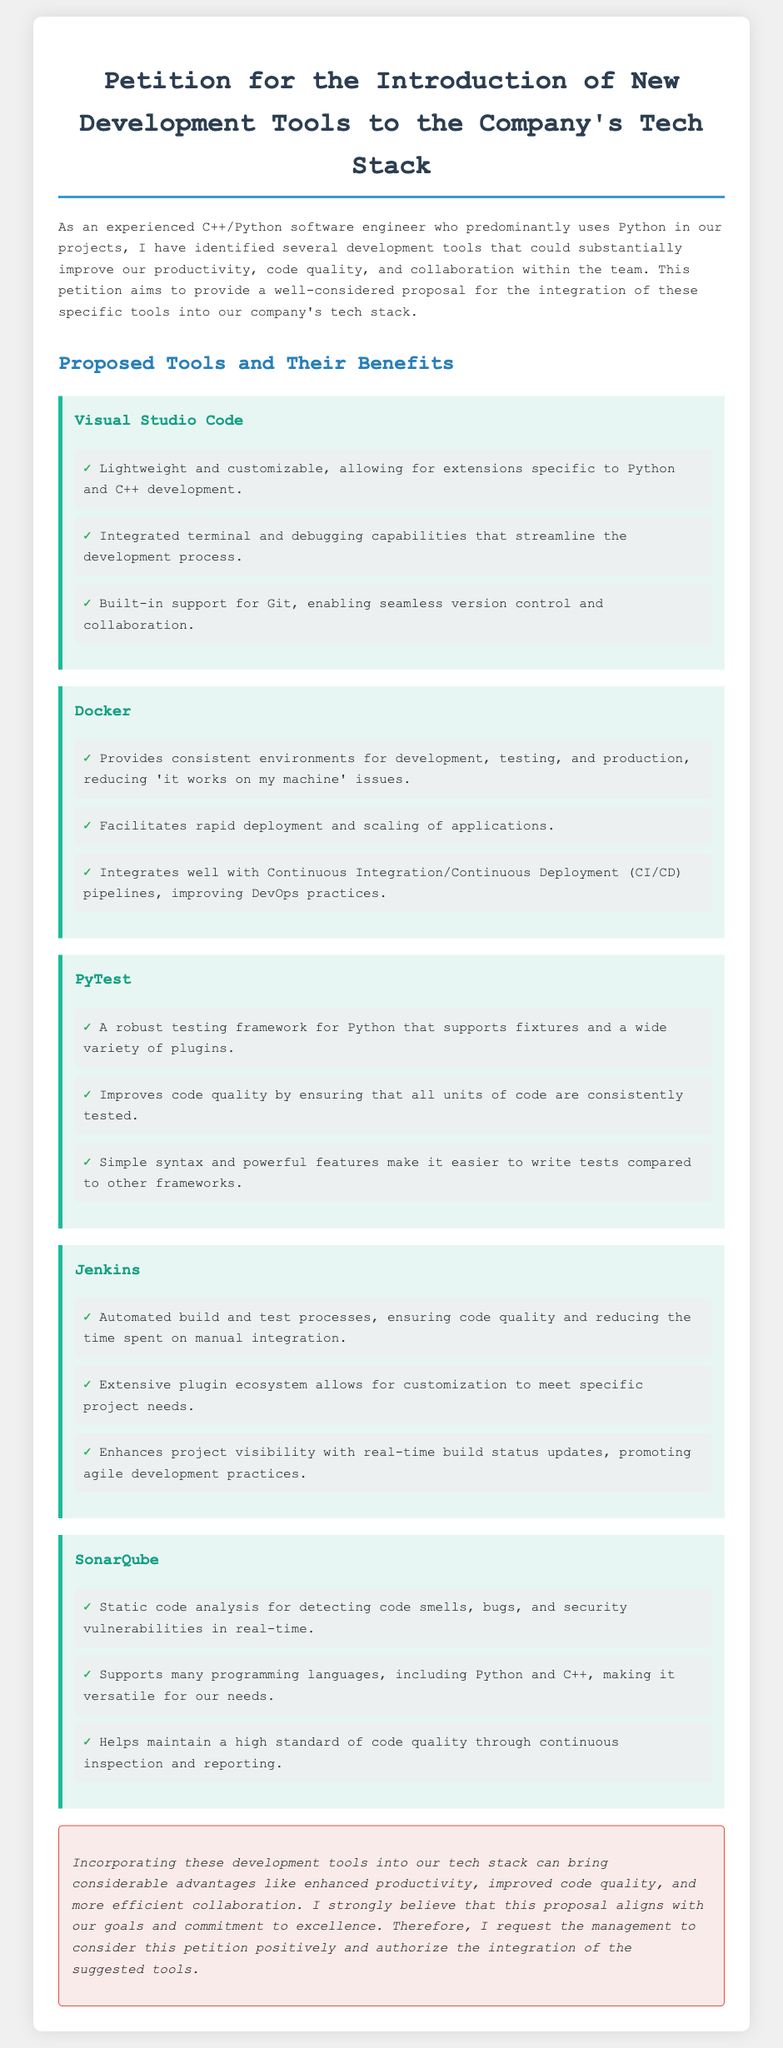What is the main purpose of the petition? The petition aims to provide a proposal for the integration of new development tools into the company's tech stack to improve productivity and collaboration.
Answer: Proposal for the integration of new development tools How many tools are proposed in the document? The document lists five specific development tools that are proposed for integration into the tech stack.
Answer: Five Which tool provides static code analysis? The document states that one of the proposed tools offers static code analysis for detecting code smells, bugs, and vulnerabilities.
Answer: SonarQube What is the benefit of using Docker mentioned in the petition? The petition highlights that Docker provides consistent environments for development, testing, and production, reducing related issues.
Answer: Reducing 'it works on my machine' issues Which tool is described as a robust testing framework for Python? The petition specifies a particular tool that is designed for testing Python code and supports features like fixtures.
Answer: PyTest What is the conclusion of the petition? The conclusion summarizes the benefits of incorporating the proposed tools into the tech stack and requests management's approval.
Answer: Request for management's approval What is an advantage of using Jenkins according to the document? The document lists several advantages of Jenkins, including automating build and test processes to ensure code quality.
Answer: Automating build and test processes Which tool integrates well with CI/CD pipelines? The document notes that one specific tool is particularly beneficial for improving CI/CD practices.
Answer: Docker 